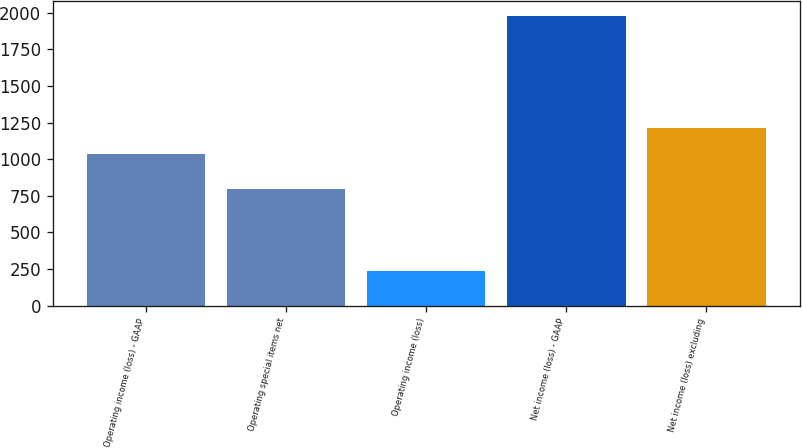Convert chart. <chart><loc_0><loc_0><loc_500><loc_500><bar_chart><fcel>Operating income (loss) - GAAP<fcel>Operating special items net<fcel>Operating income (loss)<fcel>Net income (loss) - GAAP<fcel>Net income (loss) excluding<nl><fcel>1037<fcel>799<fcel>238<fcel>1979<fcel>1211.1<nl></chart> 